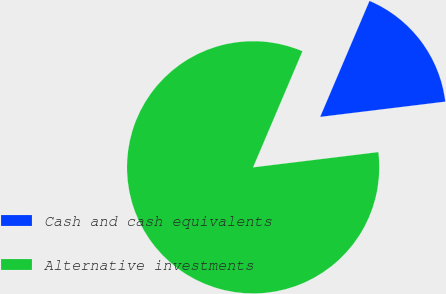<chart> <loc_0><loc_0><loc_500><loc_500><pie_chart><fcel>Cash and cash equivalents<fcel>Alternative investments<nl><fcel>16.67%<fcel>83.33%<nl></chart> 